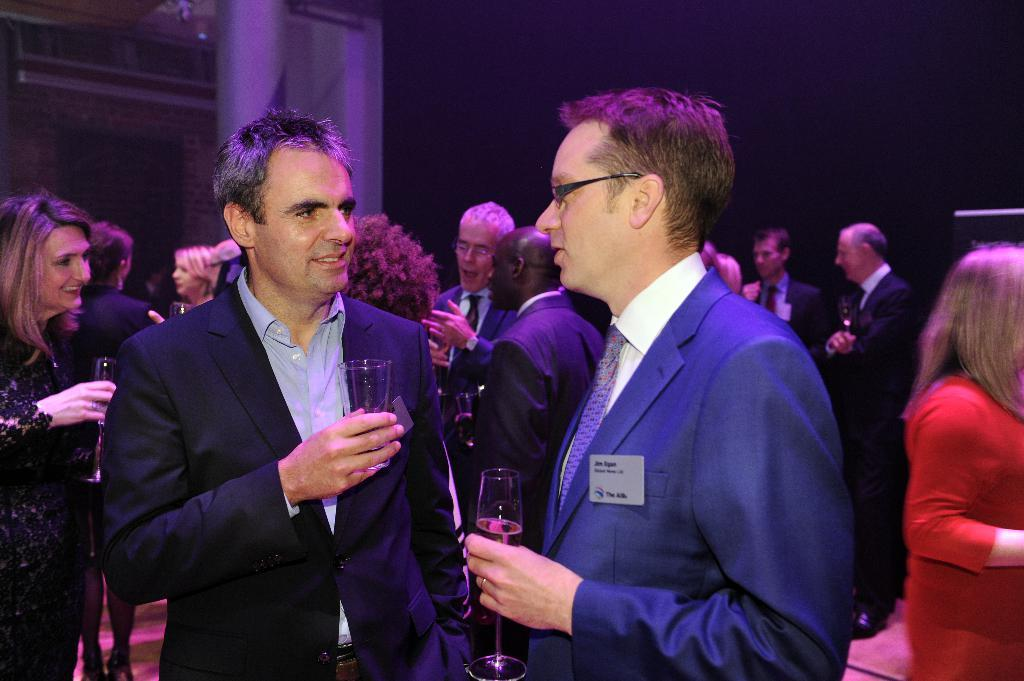Who or what can be seen in the image? There are people in the image. What are some of the people doing in the image? Some of the people are standing. What objects are being held by some of the people? Some people are holding glasses in their hands. Where are the tomatoes stored in the image? There are no tomatoes present in the image. What type of substance is being consumed by the people in the image? The provided facts do not mention any specific substance being consumed by the people in the image. 